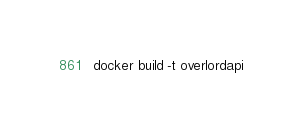<code> <loc_0><loc_0><loc_500><loc_500><_Bash_>docker build -t overlordapi</code> 